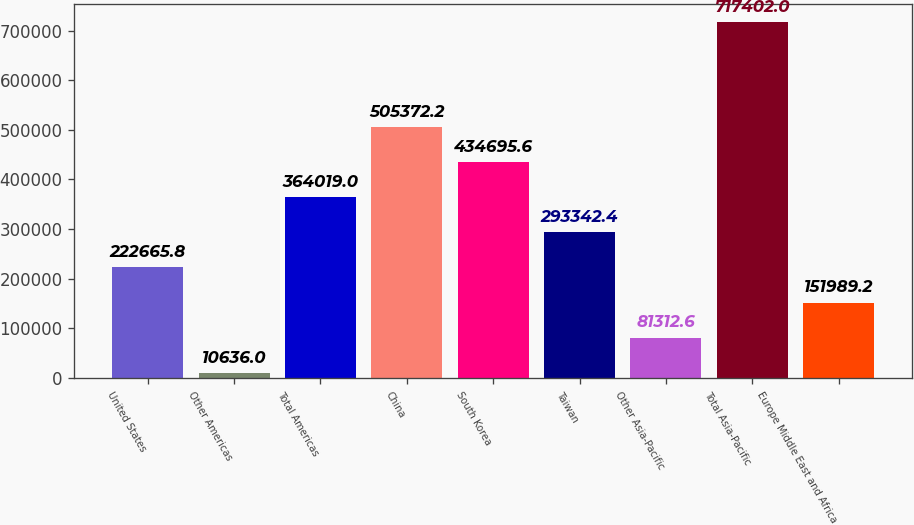Convert chart. <chart><loc_0><loc_0><loc_500><loc_500><bar_chart><fcel>United States<fcel>Other Americas<fcel>Total Americas<fcel>China<fcel>South Korea<fcel>Taiwan<fcel>Other Asia-Pacific<fcel>Total Asia-Pacific<fcel>Europe Middle East and Africa<nl><fcel>222666<fcel>10636<fcel>364019<fcel>505372<fcel>434696<fcel>293342<fcel>81312.6<fcel>717402<fcel>151989<nl></chart> 